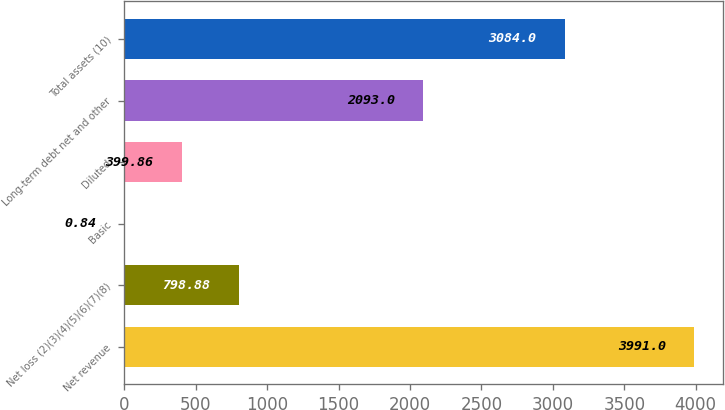Convert chart. <chart><loc_0><loc_0><loc_500><loc_500><bar_chart><fcel>Net revenue<fcel>Net loss (2)(3)(4)(5)(6)(7)(8)<fcel>Basic<fcel>Diluted<fcel>Long-term debt net and other<fcel>Total assets (10)<nl><fcel>3991<fcel>798.88<fcel>0.84<fcel>399.86<fcel>2093<fcel>3084<nl></chart> 